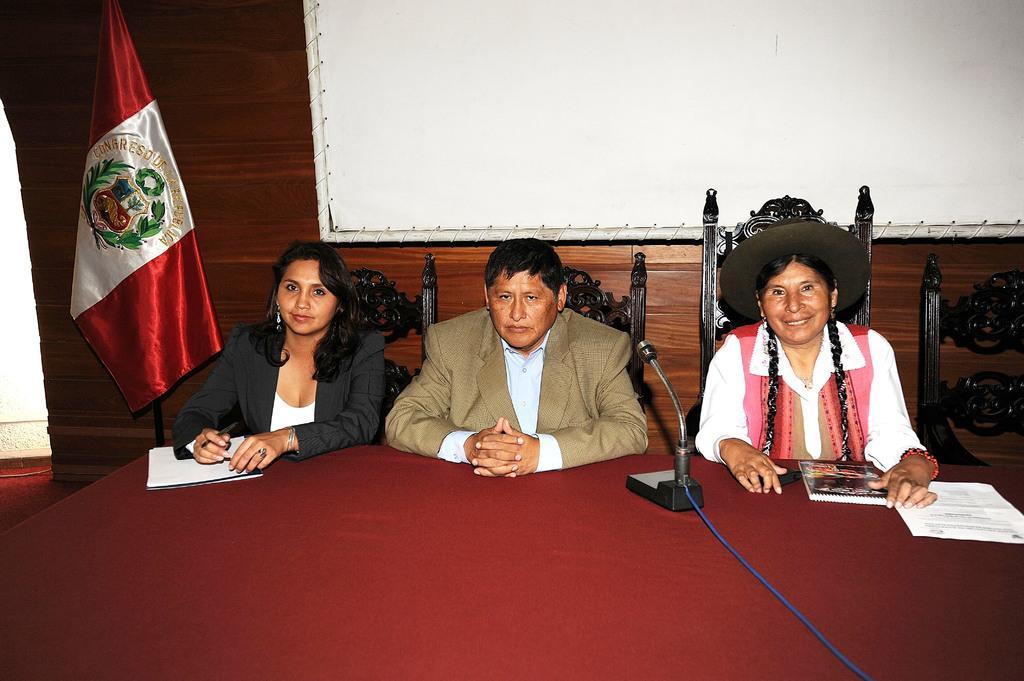How would you summarize this image in a sentence or two? In this image I can see three persons sitting. In front the person is wearing brown color blazer, white shirt and I can also see the microphone and few papers on the table. Background I can see the flag in white and red color and I can also see the board attached to the wooden wall. 